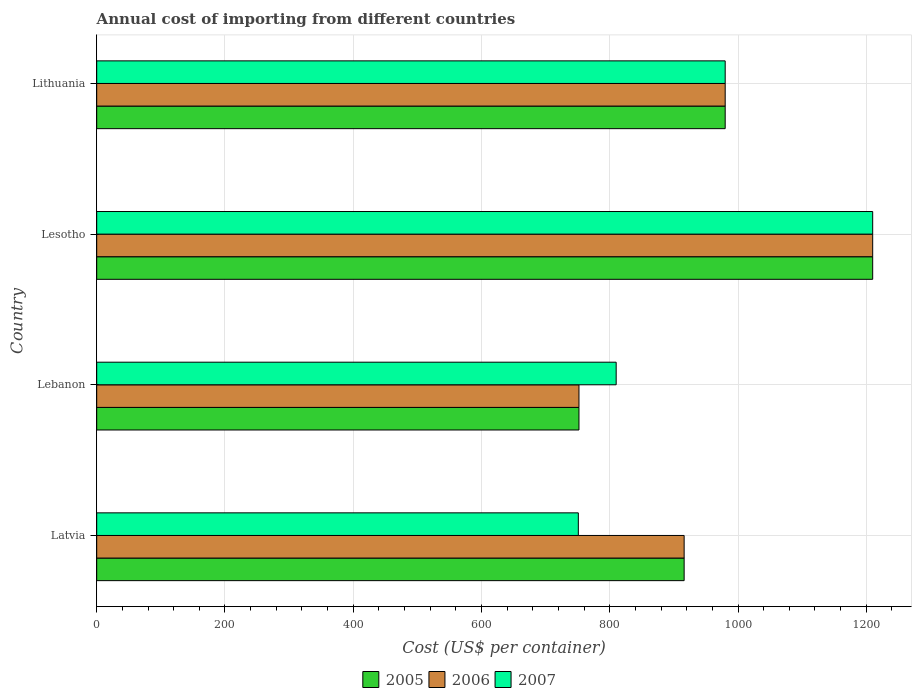How many different coloured bars are there?
Provide a short and direct response. 3. How many groups of bars are there?
Provide a succinct answer. 4. How many bars are there on the 4th tick from the bottom?
Keep it short and to the point. 3. What is the label of the 4th group of bars from the top?
Ensure brevity in your answer.  Latvia. What is the total annual cost of importing in 2005 in Lesotho?
Your response must be concise. 1210. Across all countries, what is the maximum total annual cost of importing in 2005?
Offer a very short reply. 1210. Across all countries, what is the minimum total annual cost of importing in 2006?
Provide a short and direct response. 752. In which country was the total annual cost of importing in 2005 maximum?
Give a very brief answer. Lesotho. In which country was the total annual cost of importing in 2006 minimum?
Offer a terse response. Lebanon. What is the total total annual cost of importing in 2007 in the graph?
Make the answer very short. 3751. What is the difference between the total annual cost of importing in 2005 in Latvia and that in Lebanon?
Keep it short and to the point. 164. What is the difference between the total annual cost of importing in 2005 in Lebanon and the total annual cost of importing in 2006 in Latvia?
Your answer should be compact. -164. What is the average total annual cost of importing in 2007 per country?
Ensure brevity in your answer.  937.75. What is the ratio of the total annual cost of importing in 2007 in Lebanon to that in Lithuania?
Your response must be concise. 0.83. Is the difference between the total annual cost of importing in 2007 in Latvia and Lesotho greater than the difference between the total annual cost of importing in 2005 in Latvia and Lesotho?
Your answer should be compact. No. What is the difference between the highest and the second highest total annual cost of importing in 2007?
Provide a succinct answer. 230. What is the difference between the highest and the lowest total annual cost of importing in 2006?
Provide a short and direct response. 458. Is the sum of the total annual cost of importing in 2005 in Latvia and Lebanon greater than the maximum total annual cost of importing in 2006 across all countries?
Offer a very short reply. Yes. What does the 1st bar from the bottom in Lebanon represents?
Keep it short and to the point. 2005. Is it the case that in every country, the sum of the total annual cost of importing in 2007 and total annual cost of importing in 2006 is greater than the total annual cost of importing in 2005?
Keep it short and to the point. Yes. Are all the bars in the graph horizontal?
Ensure brevity in your answer.  Yes. Are the values on the major ticks of X-axis written in scientific E-notation?
Offer a terse response. No. Does the graph contain any zero values?
Your answer should be very brief. No. Where does the legend appear in the graph?
Your answer should be compact. Bottom center. How many legend labels are there?
Make the answer very short. 3. How are the legend labels stacked?
Keep it short and to the point. Horizontal. What is the title of the graph?
Your answer should be very brief. Annual cost of importing from different countries. What is the label or title of the X-axis?
Your answer should be very brief. Cost (US$ per container). What is the label or title of the Y-axis?
Give a very brief answer. Country. What is the Cost (US$ per container) in 2005 in Latvia?
Provide a succinct answer. 916. What is the Cost (US$ per container) of 2006 in Latvia?
Offer a very short reply. 916. What is the Cost (US$ per container) in 2007 in Latvia?
Offer a very short reply. 751. What is the Cost (US$ per container) of 2005 in Lebanon?
Provide a succinct answer. 752. What is the Cost (US$ per container) of 2006 in Lebanon?
Offer a very short reply. 752. What is the Cost (US$ per container) in 2007 in Lebanon?
Keep it short and to the point. 810. What is the Cost (US$ per container) in 2005 in Lesotho?
Give a very brief answer. 1210. What is the Cost (US$ per container) in 2006 in Lesotho?
Provide a succinct answer. 1210. What is the Cost (US$ per container) in 2007 in Lesotho?
Provide a short and direct response. 1210. What is the Cost (US$ per container) in 2005 in Lithuania?
Your response must be concise. 980. What is the Cost (US$ per container) of 2006 in Lithuania?
Provide a succinct answer. 980. What is the Cost (US$ per container) of 2007 in Lithuania?
Your response must be concise. 980. Across all countries, what is the maximum Cost (US$ per container) in 2005?
Your answer should be very brief. 1210. Across all countries, what is the maximum Cost (US$ per container) in 2006?
Give a very brief answer. 1210. Across all countries, what is the maximum Cost (US$ per container) in 2007?
Ensure brevity in your answer.  1210. Across all countries, what is the minimum Cost (US$ per container) of 2005?
Offer a very short reply. 752. Across all countries, what is the minimum Cost (US$ per container) in 2006?
Offer a terse response. 752. Across all countries, what is the minimum Cost (US$ per container) of 2007?
Give a very brief answer. 751. What is the total Cost (US$ per container) in 2005 in the graph?
Ensure brevity in your answer.  3858. What is the total Cost (US$ per container) of 2006 in the graph?
Your answer should be very brief. 3858. What is the total Cost (US$ per container) in 2007 in the graph?
Provide a short and direct response. 3751. What is the difference between the Cost (US$ per container) of 2005 in Latvia and that in Lebanon?
Offer a terse response. 164. What is the difference between the Cost (US$ per container) in 2006 in Latvia and that in Lebanon?
Your answer should be very brief. 164. What is the difference between the Cost (US$ per container) of 2007 in Latvia and that in Lebanon?
Your response must be concise. -59. What is the difference between the Cost (US$ per container) of 2005 in Latvia and that in Lesotho?
Offer a very short reply. -294. What is the difference between the Cost (US$ per container) of 2006 in Latvia and that in Lesotho?
Your answer should be compact. -294. What is the difference between the Cost (US$ per container) of 2007 in Latvia and that in Lesotho?
Your response must be concise. -459. What is the difference between the Cost (US$ per container) in 2005 in Latvia and that in Lithuania?
Your answer should be compact. -64. What is the difference between the Cost (US$ per container) of 2006 in Latvia and that in Lithuania?
Make the answer very short. -64. What is the difference between the Cost (US$ per container) of 2007 in Latvia and that in Lithuania?
Your answer should be compact. -229. What is the difference between the Cost (US$ per container) in 2005 in Lebanon and that in Lesotho?
Provide a succinct answer. -458. What is the difference between the Cost (US$ per container) of 2006 in Lebanon and that in Lesotho?
Keep it short and to the point. -458. What is the difference between the Cost (US$ per container) of 2007 in Lebanon and that in Lesotho?
Ensure brevity in your answer.  -400. What is the difference between the Cost (US$ per container) of 2005 in Lebanon and that in Lithuania?
Your answer should be very brief. -228. What is the difference between the Cost (US$ per container) of 2006 in Lebanon and that in Lithuania?
Make the answer very short. -228. What is the difference between the Cost (US$ per container) of 2007 in Lebanon and that in Lithuania?
Keep it short and to the point. -170. What is the difference between the Cost (US$ per container) of 2005 in Lesotho and that in Lithuania?
Provide a succinct answer. 230. What is the difference between the Cost (US$ per container) in 2006 in Lesotho and that in Lithuania?
Ensure brevity in your answer.  230. What is the difference between the Cost (US$ per container) in 2007 in Lesotho and that in Lithuania?
Your response must be concise. 230. What is the difference between the Cost (US$ per container) in 2005 in Latvia and the Cost (US$ per container) in 2006 in Lebanon?
Your answer should be very brief. 164. What is the difference between the Cost (US$ per container) of 2005 in Latvia and the Cost (US$ per container) of 2007 in Lebanon?
Provide a short and direct response. 106. What is the difference between the Cost (US$ per container) of 2006 in Latvia and the Cost (US$ per container) of 2007 in Lebanon?
Offer a terse response. 106. What is the difference between the Cost (US$ per container) of 2005 in Latvia and the Cost (US$ per container) of 2006 in Lesotho?
Keep it short and to the point. -294. What is the difference between the Cost (US$ per container) of 2005 in Latvia and the Cost (US$ per container) of 2007 in Lesotho?
Offer a very short reply. -294. What is the difference between the Cost (US$ per container) of 2006 in Latvia and the Cost (US$ per container) of 2007 in Lesotho?
Offer a terse response. -294. What is the difference between the Cost (US$ per container) of 2005 in Latvia and the Cost (US$ per container) of 2006 in Lithuania?
Make the answer very short. -64. What is the difference between the Cost (US$ per container) in 2005 in Latvia and the Cost (US$ per container) in 2007 in Lithuania?
Give a very brief answer. -64. What is the difference between the Cost (US$ per container) in 2006 in Latvia and the Cost (US$ per container) in 2007 in Lithuania?
Your answer should be compact. -64. What is the difference between the Cost (US$ per container) of 2005 in Lebanon and the Cost (US$ per container) of 2006 in Lesotho?
Your answer should be very brief. -458. What is the difference between the Cost (US$ per container) of 2005 in Lebanon and the Cost (US$ per container) of 2007 in Lesotho?
Offer a terse response. -458. What is the difference between the Cost (US$ per container) of 2006 in Lebanon and the Cost (US$ per container) of 2007 in Lesotho?
Provide a short and direct response. -458. What is the difference between the Cost (US$ per container) of 2005 in Lebanon and the Cost (US$ per container) of 2006 in Lithuania?
Your answer should be compact. -228. What is the difference between the Cost (US$ per container) in 2005 in Lebanon and the Cost (US$ per container) in 2007 in Lithuania?
Make the answer very short. -228. What is the difference between the Cost (US$ per container) in 2006 in Lebanon and the Cost (US$ per container) in 2007 in Lithuania?
Offer a very short reply. -228. What is the difference between the Cost (US$ per container) in 2005 in Lesotho and the Cost (US$ per container) in 2006 in Lithuania?
Offer a terse response. 230. What is the difference between the Cost (US$ per container) of 2005 in Lesotho and the Cost (US$ per container) of 2007 in Lithuania?
Your answer should be compact. 230. What is the difference between the Cost (US$ per container) of 2006 in Lesotho and the Cost (US$ per container) of 2007 in Lithuania?
Make the answer very short. 230. What is the average Cost (US$ per container) in 2005 per country?
Your response must be concise. 964.5. What is the average Cost (US$ per container) in 2006 per country?
Provide a short and direct response. 964.5. What is the average Cost (US$ per container) of 2007 per country?
Provide a short and direct response. 937.75. What is the difference between the Cost (US$ per container) in 2005 and Cost (US$ per container) in 2007 in Latvia?
Ensure brevity in your answer.  165. What is the difference between the Cost (US$ per container) of 2006 and Cost (US$ per container) of 2007 in Latvia?
Give a very brief answer. 165. What is the difference between the Cost (US$ per container) of 2005 and Cost (US$ per container) of 2007 in Lebanon?
Provide a succinct answer. -58. What is the difference between the Cost (US$ per container) in 2006 and Cost (US$ per container) in 2007 in Lebanon?
Provide a succinct answer. -58. What is the difference between the Cost (US$ per container) in 2005 and Cost (US$ per container) in 2007 in Lesotho?
Your answer should be compact. 0. What is the difference between the Cost (US$ per container) in 2006 and Cost (US$ per container) in 2007 in Lesotho?
Provide a short and direct response. 0. What is the difference between the Cost (US$ per container) in 2005 and Cost (US$ per container) in 2006 in Lithuania?
Offer a terse response. 0. What is the ratio of the Cost (US$ per container) of 2005 in Latvia to that in Lebanon?
Your answer should be compact. 1.22. What is the ratio of the Cost (US$ per container) in 2006 in Latvia to that in Lebanon?
Keep it short and to the point. 1.22. What is the ratio of the Cost (US$ per container) in 2007 in Latvia to that in Lebanon?
Give a very brief answer. 0.93. What is the ratio of the Cost (US$ per container) in 2005 in Latvia to that in Lesotho?
Make the answer very short. 0.76. What is the ratio of the Cost (US$ per container) of 2006 in Latvia to that in Lesotho?
Ensure brevity in your answer.  0.76. What is the ratio of the Cost (US$ per container) of 2007 in Latvia to that in Lesotho?
Ensure brevity in your answer.  0.62. What is the ratio of the Cost (US$ per container) in 2005 in Latvia to that in Lithuania?
Keep it short and to the point. 0.93. What is the ratio of the Cost (US$ per container) of 2006 in Latvia to that in Lithuania?
Offer a very short reply. 0.93. What is the ratio of the Cost (US$ per container) of 2007 in Latvia to that in Lithuania?
Offer a very short reply. 0.77. What is the ratio of the Cost (US$ per container) in 2005 in Lebanon to that in Lesotho?
Make the answer very short. 0.62. What is the ratio of the Cost (US$ per container) in 2006 in Lebanon to that in Lesotho?
Ensure brevity in your answer.  0.62. What is the ratio of the Cost (US$ per container) of 2007 in Lebanon to that in Lesotho?
Provide a succinct answer. 0.67. What is the ratio of the Cost (US$ per container) of 2005 in Lebanon to that in Lithuania?
Your answer should be compact. 0.77. What is the ratio of the Cost (US$ per container) in 2006 in Lebanon to that in Lithuania?
Make the answer very short. 0.77. What is the ratio of the Cost (US$ per container) of 2007 in Lebanon to that in Lithuania?
Keep it short and to the point. 0.83. What is the ratio of the Cost (US$ per container) in 2005 in Lesotho to that in Lithuania?
Your answer should be compact. 1.23. What is the ratio of the Cost (US$ per container) in 2006 in Lesotho to that in Lithuania?
Make the answer very short. 1.23. What is the ratio of the Cost (US$ per container) of 2007 in Lesotho to that in Lithuania?
Offer a terse response. 1.23. What is the difference between the highest and the second highest Cost (US$ per container) of 2005?
Give a very brief answer. 230. What is the difference between the highest and the second highest Cost (US$ per container) in 2006?
Your response must be concise. 230. What is the difference between the highest and the second highest Cost (US$ per container) of 2007?
Your answer should be compact. 230. What is the difference between the highest and the lowest Cost (US$ per container) in 2005?
Ensure brevity in your answer.  458. What is the difference between the highest and the lowest Cost (US$ per container) of 2006?
Ensure brevity in your answer.  458. What is the difference between the highest and the lowest Cost (US$ per container) of 2007?
Your response must be concise. 459. 